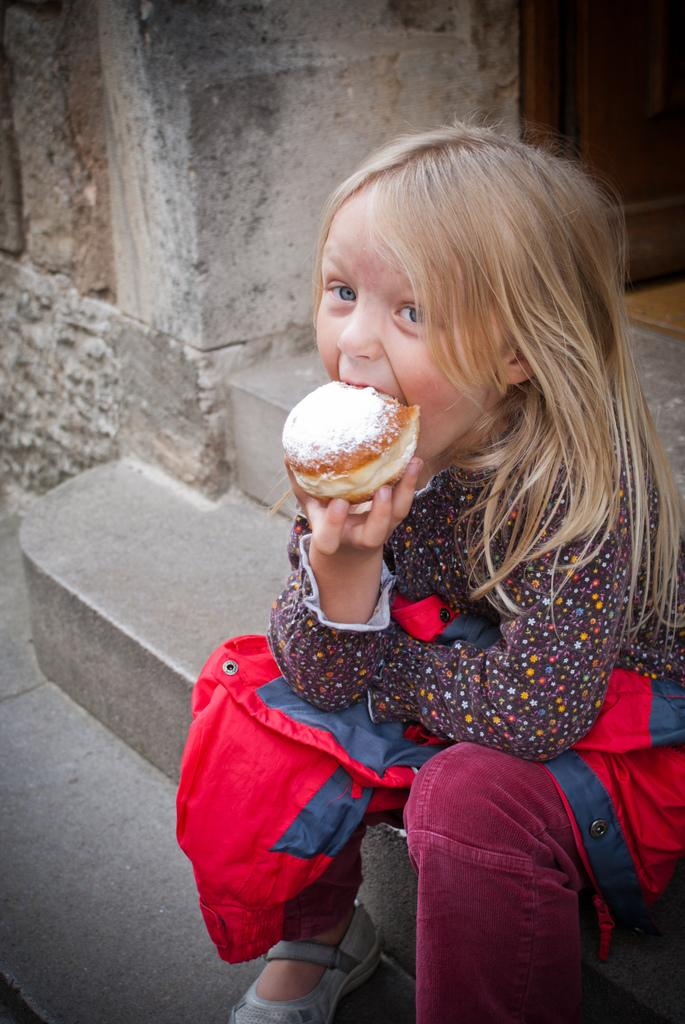Who is the main subject in the image? There is a girl in the image. What is the girl doing in the image? The girl is sitting and eating. Where is the girl located in the image? The girl is on staircases. What word is the girl saying while eating in the image? There is no indication in the image that the girl is saying any specific word while eating. 